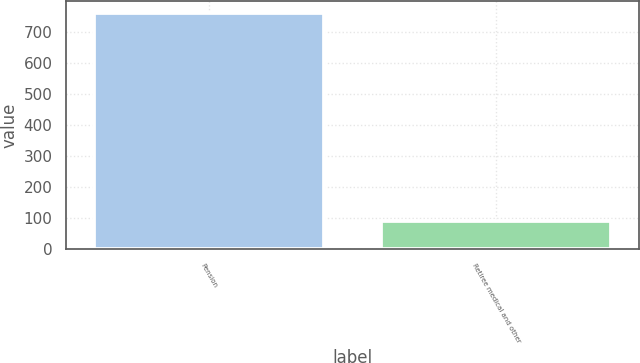Convert chart to OTSL. <chart><loc_0><loc_0><loc_500><loc_500><bar_chart><fcel>Pension<fcel>Retiree medical and other<nl><fcel>761<fcel>90<nl></chart> 